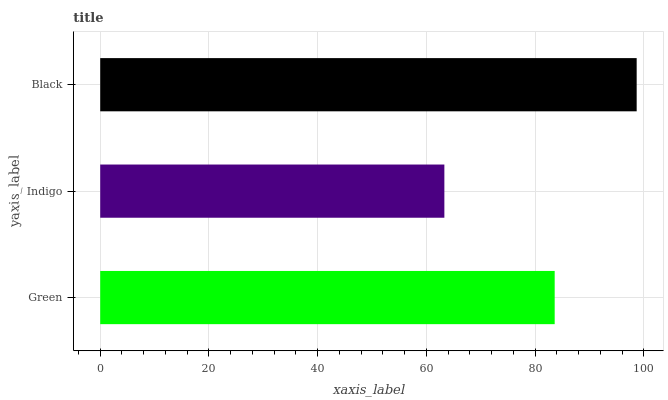Is Indigo the minimum?
Answer yes or no. Yes. Is Black the maximum?
Answer yes or no. Yes. Is Black the minimum?
Answer yes or no. No. Is Indigo the maximum?
Answer yes or no. No. Is Black greater than Indigo?
Answer yes or no. Yes. Is Indigo less than Black?
Answer yes or no. Yes. Is Indigo greater than Black?
Answer yes or no. No. Is Black less than Indigo?
Answer yes or no. No. Is Green the high median?
Answer yes or no. Yes. Is Green the low median?
Answer yes or no. Yes. Is Black the high median?
Answer yes or no. No. Is Indigo the low median?
Answer yes or no. No. 